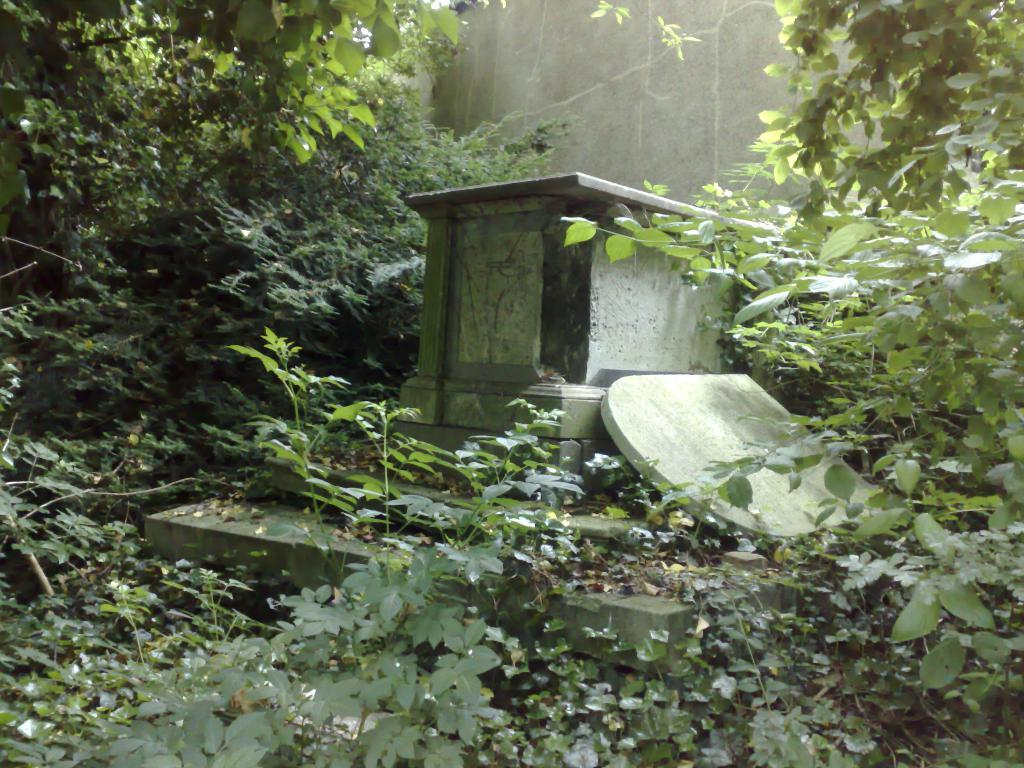What structure is located in the middle of the picture? There is an outhouse in the middle of the picture. What architectural feature is also present in the middle of the picture? There is a staircase in the middle of the picture. What can be seen in the background of the image? There is a wall visible in the image. What type of natural environment is depicted in the image? There are many trees in the image. Can you see a robin perched on the outhouse in the image? There is no robin present in the image. What type of coil is used to support the staircase in the image? The image does not show any coils supporting the staircase; it only shows the staircase and the outhouse. 